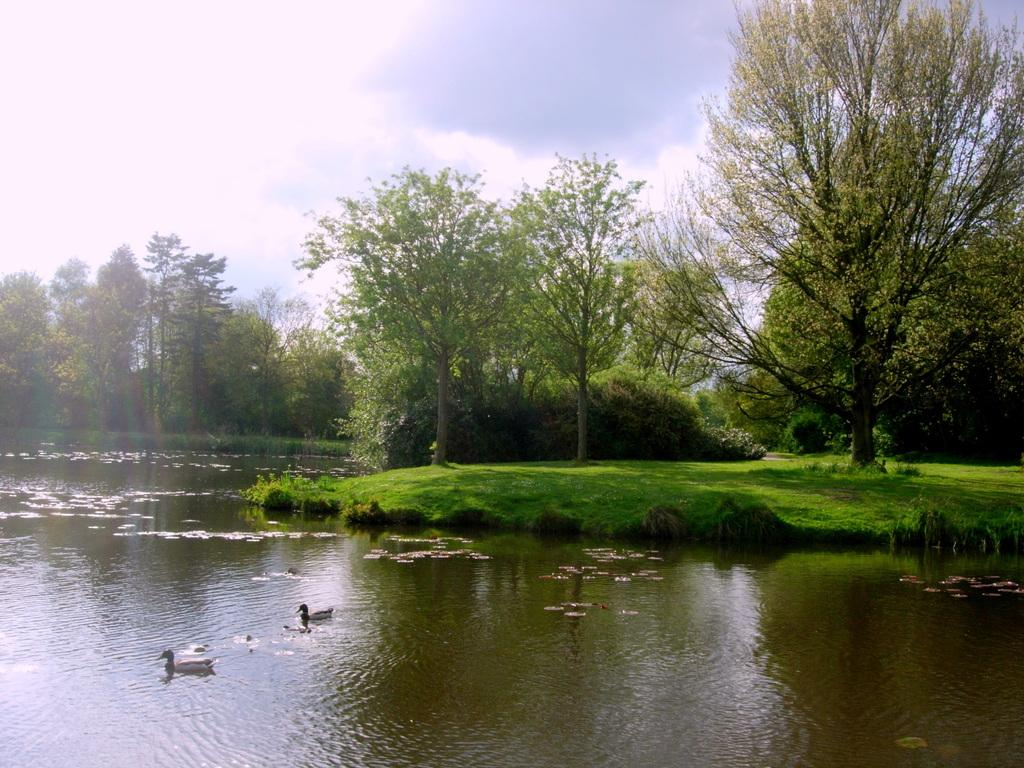What type of animals can be seen in the image? There are birds in the image. What is present in the water body? There are leaves in the water body. What is the primary feature of the image? There is a water body in the image. What type of vegetation is visible in the image? There is grass and plants visible in the image. What is the group of trees in the image called? The group of trees in the image is called a forest or a grove. What is visible in the sky in the image? The sky is visible in the image, and it appears cloudy. Where is the glove located in the image? There is no glove present in the image. What type of test is being conducted in the image? There is no test being conducted in the image. 